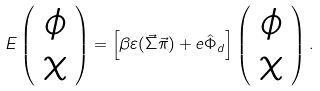Convert formula to latex. <formula><loc_0><loc_0><loc_500><loc_500>E \left ( \begin{array} { c c } \phi \\ \chi \\ \end{array} \right ) = \left [ \beta \varepsilon ( \vec { \Sigma } \vec { \pi } ) + e \hat { \Phi } _ { d } \right ] \left ( \begin{array} { c c } \phi \\ \chi \\ \end{array} \right ) .</formula> 